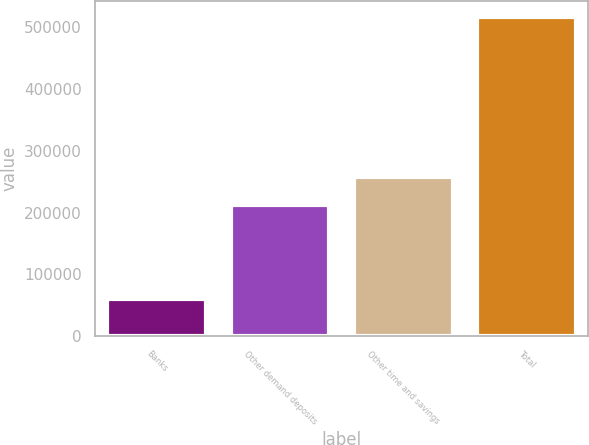Convert chart. <chart><loc_0><loc_0><loc_500><loc_500><bar_chart><fcel>Banks<fcel>Other demand deposits<fcel>Other time and savings<fcel>Total<nl><fcel>60315<fcel>212781<fcel>258390<fcel>516401<nl></chart> 